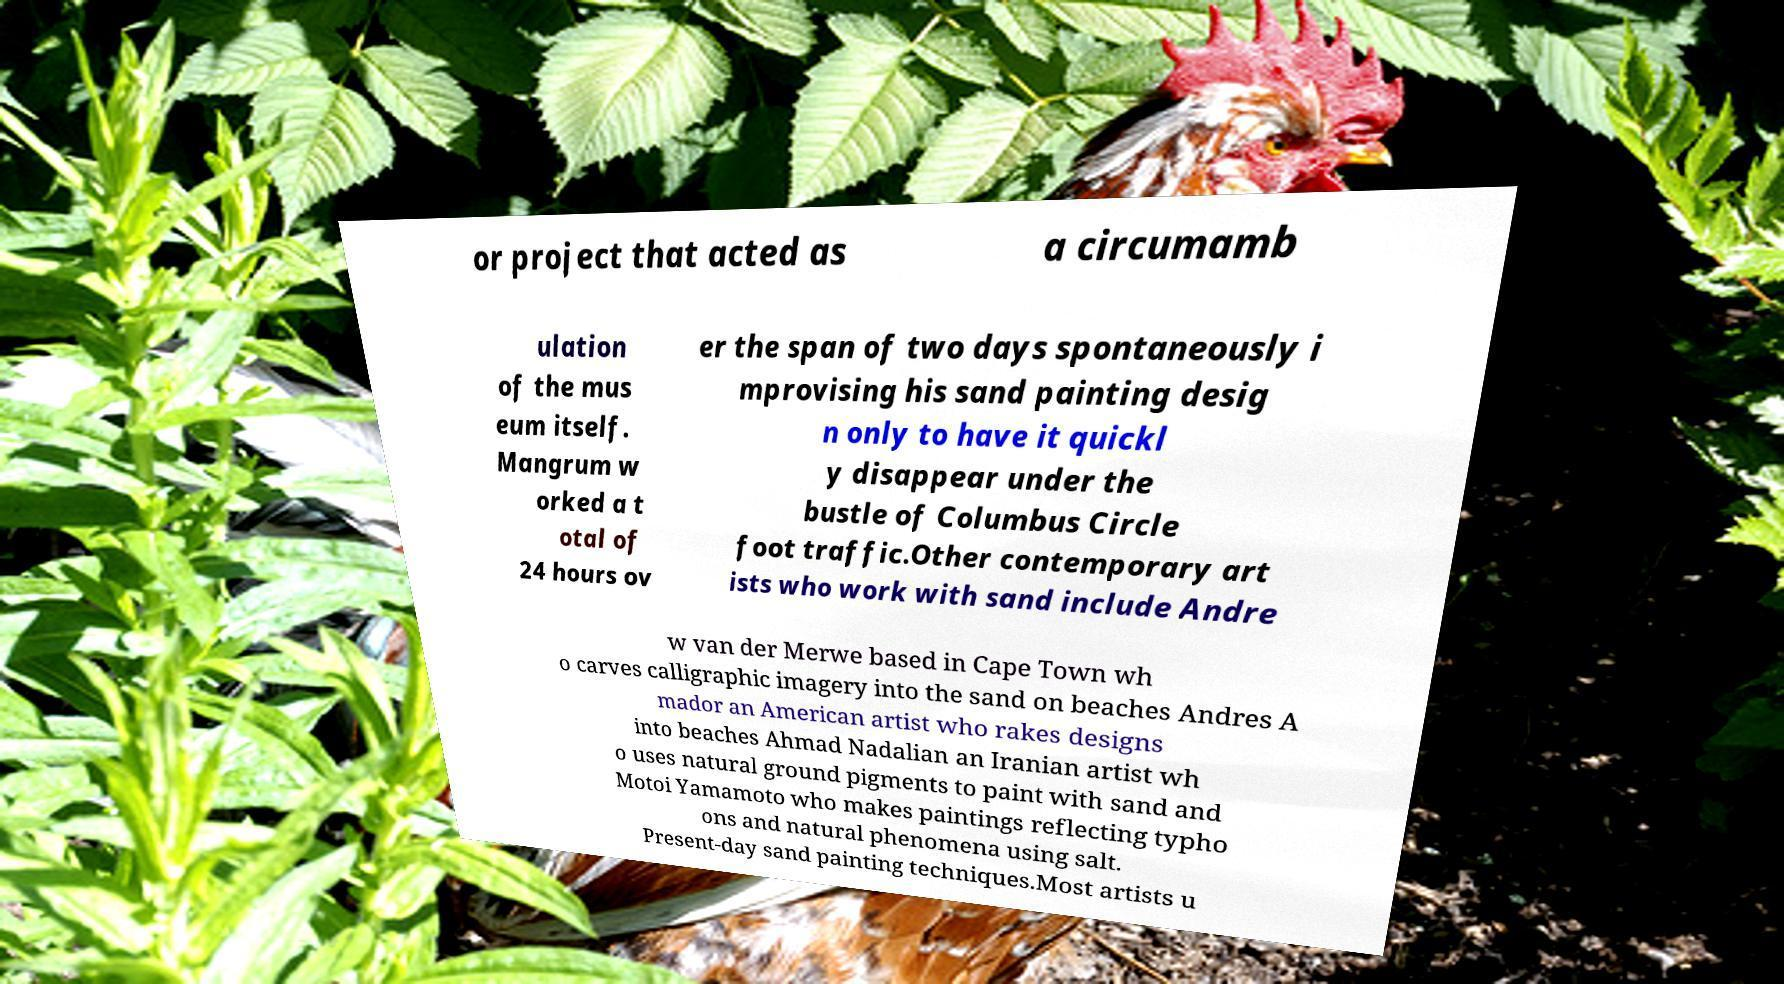Please identify and transcribe the text found in this image. or project that acted as a circumamb ulation of the mus eum itself. Mangrum w orked a t otal of 24 hours ov er the span of two days spontaneously i mprovising his sand painting desig n only to have it quickl y disappear under the bustle of Columbus Circle foot traffic.Other contemporary art ists who work with sand include Andre w van der Merwe based in Cape Town wh o carves calligraphic imagery into the sand on beaches Andres A mador an American artist who rakes designs into beaches Ahmad Nadalian an Iranian artist wh o uses natural ground pigments to paint with sand and Motoi Yamamoto who makes paintings reflecting typho ons and natural phenomena using salt. Present-day sand painting techniques.Most artists u 